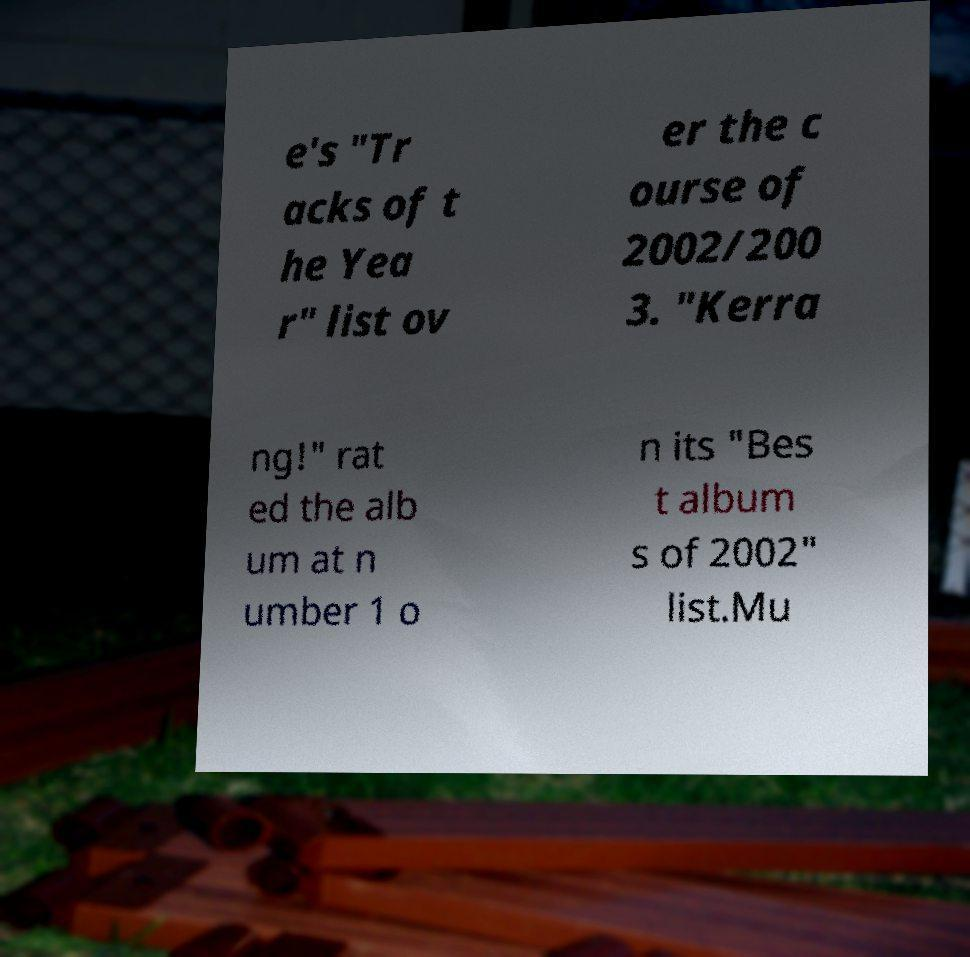Could you extract and type out the text from this image? e's "Tr acks of t he Yea r" list ov er the c ourse of 2002/200 3. "Kerra ng!" rat ed the alb um at n umber 1 o n its "Bes t album s of 2002" list.Mu 